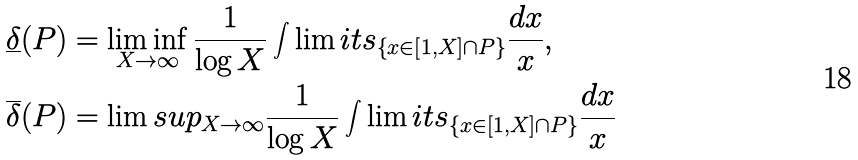<formula> <loc_0><loc_0><loc_500><loc_500>\underline { \delta } ( P ) & = \liminf _ { X \to \infty } \frac { 1 } { \log X } \int \lim i t s _ { \left \{ x \in [ 1 , X ] \cap P \right \} } { \frac { d x } { x } } , \\ \overline { \delta } ( P ) & = \lim s u p _ { X \to \infty } \frac { 1 } { \log X } \int \lim i t s _ { \left \{ x \in [ 1 , X ] \cap P \right \} } { \frac { d x } { x } }</formula> 